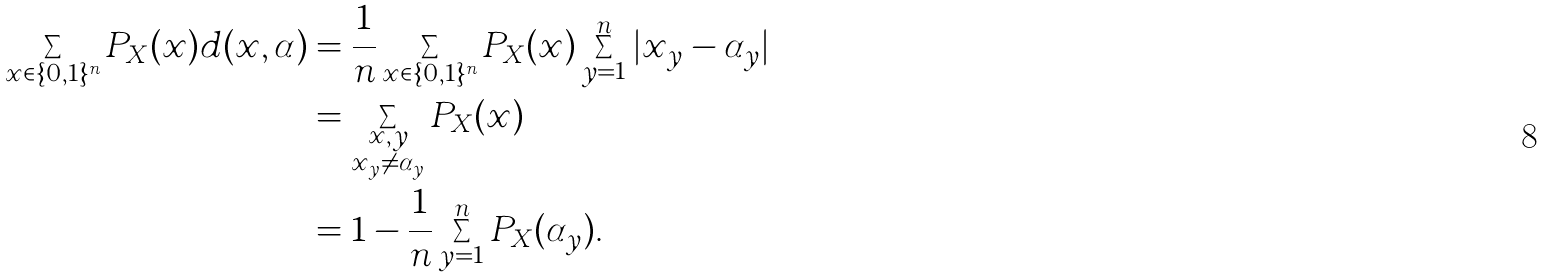<formula> <loc_0><loc_0><loc_500><loc_500>\sum _ { x \in \{ 0 , 1 \} ^ { n } } P _ { X } ( x ) d ( x , \alpha ) & = \frac { 1 } { n } \sum _ { x \in \{ 0 , 1 \} ^ { n } } P _ { X } ( x ) \sum _ { y = 1 } ^ { n } | x _ { y } - \alpha _ { y } | \\ & = \sum _ { \substack { x , y \\ x _ { y } \neq \alpha _ { y } } } P _ { X } ( x ) \\ & = 1 - \frac { 1 } { n } \sum _ { y = 1 } ^ { n } P _ { X } ( \alpha _ { y } ) .</formula> 